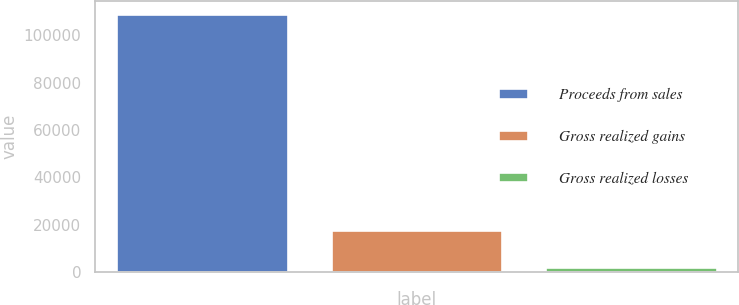Convert chart to OTSL. <chart><loc_0><loc_0><loc_500><loc_500><bar_chart><fcel>Proceeds from sales<fcel>Gross realized gains<fcel>Gross realized losses<nl><fcel>109024<fcel>17583<fcel>1879<nl></chart> 